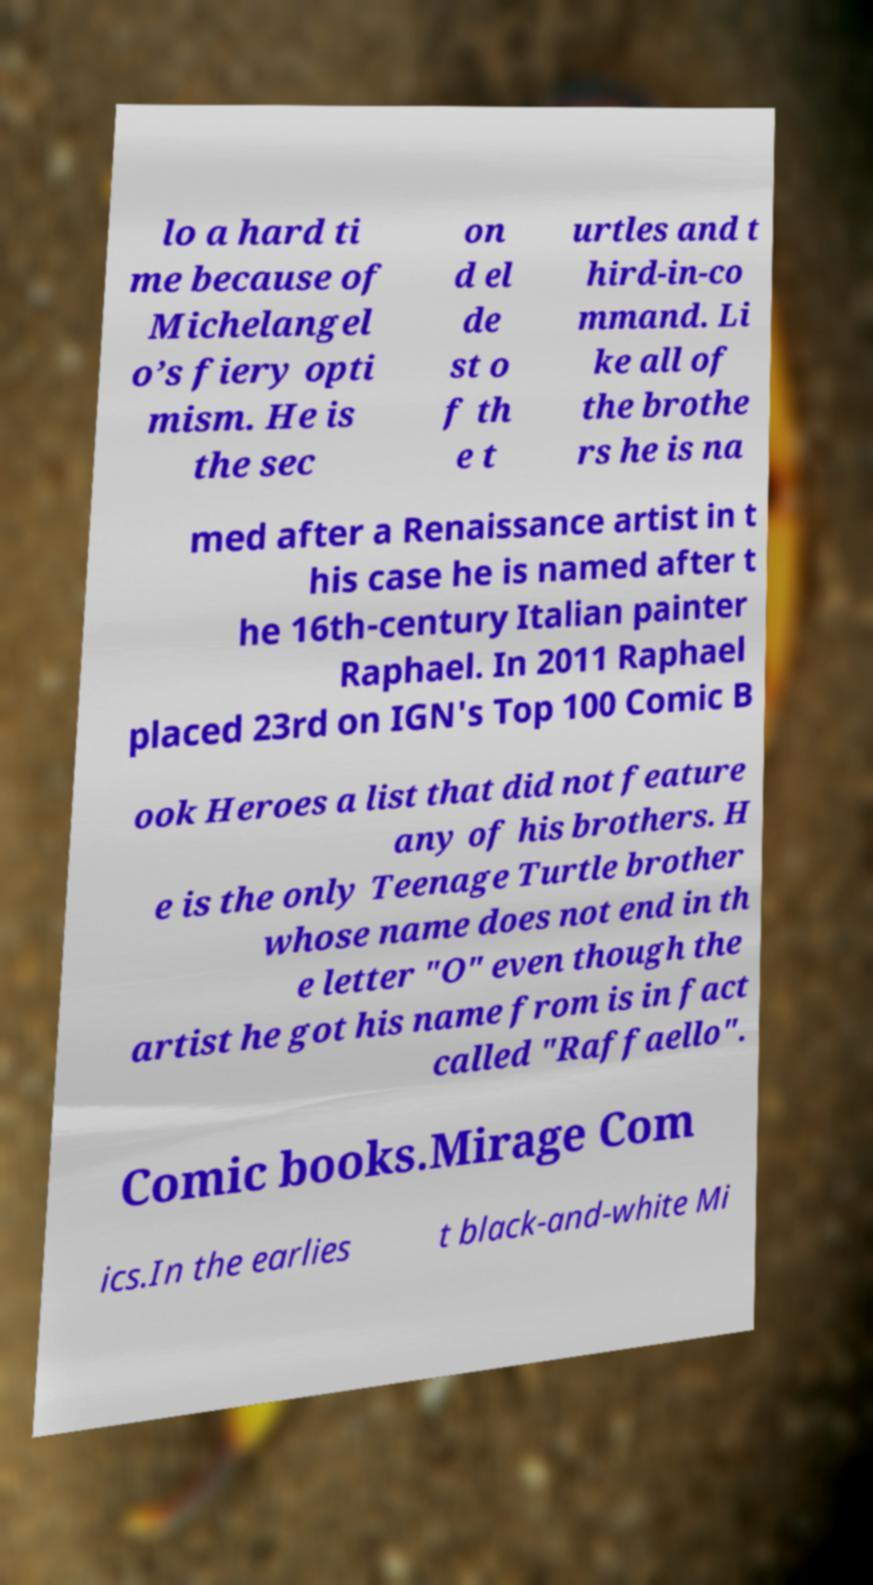For documentation purposes, I need the text within this image transcribed. Could you provide that? lo a hard ti me because of Michelangel o’s fiery opti mism. He is the sec on d el de st o f th e t urtles and t hird-in-co mmand. Li ke all of the brothe rs he is na med after a Renaissance artist in t his case he is named after t he 16th-century Italian painter Raphael. In 2011 Raphael placed 23rd on IGN's Top 100 Comic B ook Heroes a list that did not feature any of his brothers. H e is the only Teenage Turtle brother whose name does not end in th e letter "O" even though the artist he got his name from is in fact called "Raffaello". Comic books.Mirage Com ics.In the earlies t black-and-white Mi 